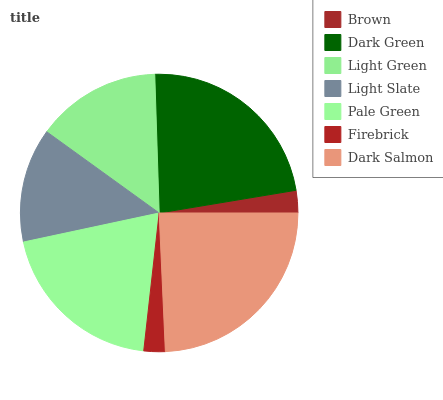Is Firebrick the minimum?
Answer yes or no. Yes. Is Dark Salmon the maximum?
Answer yes or no. Yes. Is Dark Green the minimum?
Answer yes or no. No. Is Dark Green the maximum?
Answer yes or no. No. Is Dark Green greater than Brown?
Answer yes or no. Yes. Is Brown less than Dark Green?
Answer yes or no. Yes. Is Brown greater than Dark Green?
Answer yes or no. No. Is Dark Green less than Brown?
Answer yes or no. No. Is Light Green the high median?
Answer yes or no. Yes. Is Light Green the low median?
Answer yes or no. Yes. Is Brown the high median?
Answer yes or no. No. Is Brown the low median?
Answer yes or no. No. 